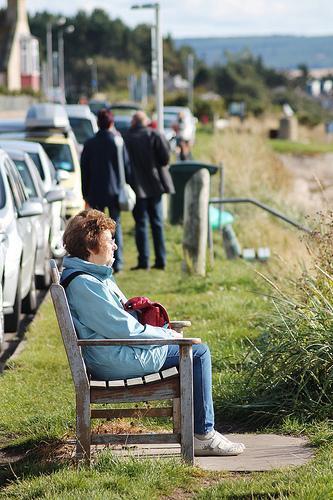How many people are sitting on a bench?
Give a very brief answer. 1. 